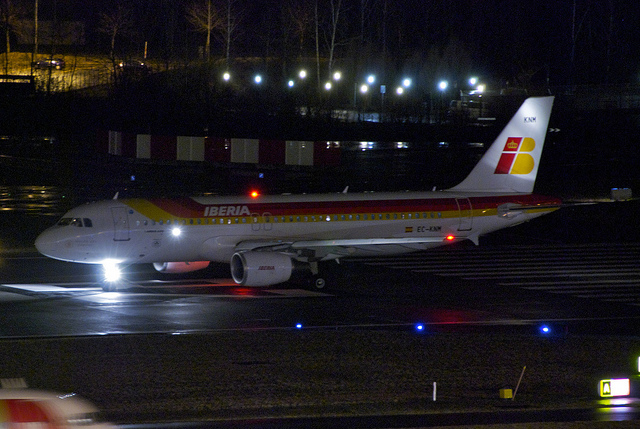Identify and read out the text in this image. IBERIA A 